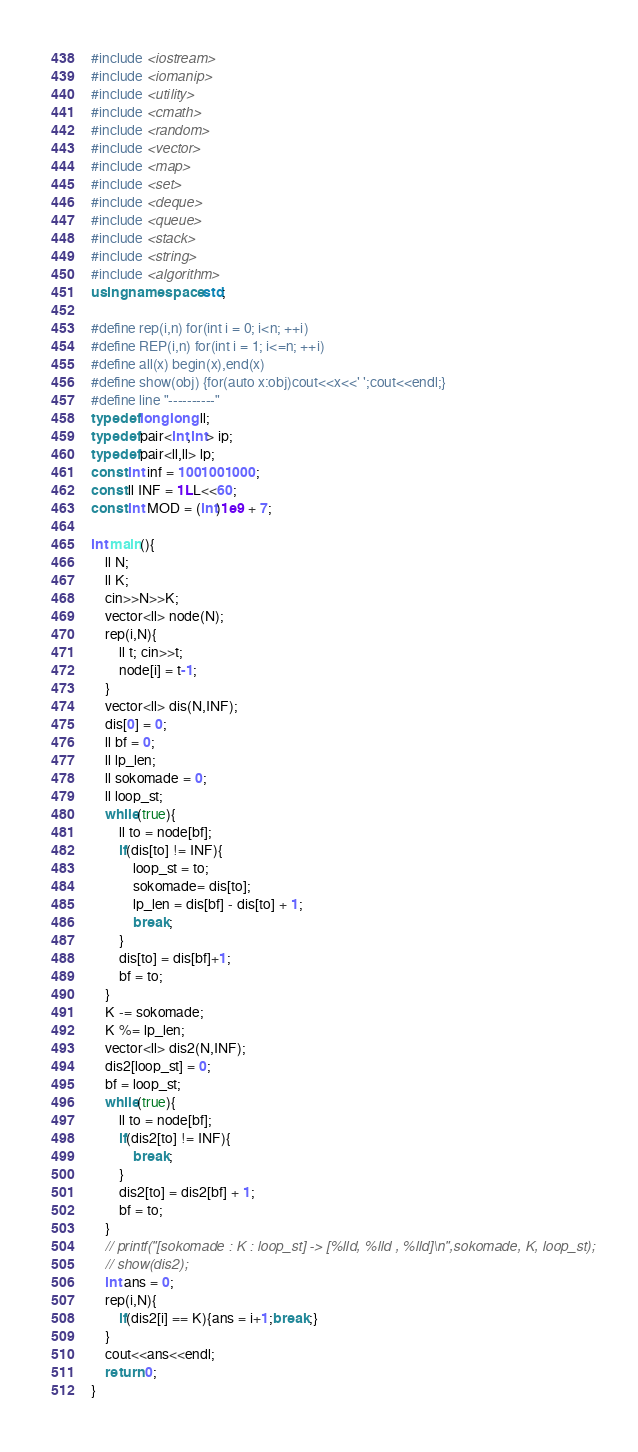Convert code to text. <code><loc_0><loc_0><loc_500><loc_500><_C++_>#include <iostream>
#include <iomanip>
#include <utility>
#include <cmath>
#include <random>
#include <vector>
#include <map>
#include <set>
#include <deque>
#include <queue>
#include <stack>
#include <string>
#include <algorithm>
using namespace std;

#define rep(i,n) for(int i = 0; i<n; ++i)
#define REP(i,n) for(int i = 1; i<=n; ++i)
#define all(x) begin(x),end(x)
#define show(obj) {for(auto x:obj)cout<<x<<' ';cout<<endl;}
#define line "----------"
typedef long long ll;
typedef pair<int,int> ip;
typedef pair<ll,ll> lp;
const int inf = 1001001000;
const ll INF = 1LL<<60;
const int MOD = (int)1e9 + 7;

int main(){
	ll N;
	ll K;
	cin>>N>>K;
	vector<ll> node(N);
	rep(i,N){
		ll t; cin>>t;
		node[i] = t-1;
	}
	vector<ll> dis(N,INF);
	dis[0] = 0;
	ll bf = 0;
	ll lp_len;
	ll sokomade = 0;
	ll loop_st;
	while(true){
		ll to = node[bf];
		if(dis[to] != INF){
			loop_st = to;
			sokomade= dis[to];
			lp_len = dis[bf] - dis[to] + 1;
			break;
		}
		dis[to] = dis[bf]+1;
		bf = to;
	}
	K -= sokomade;
	K %= lp_len;
	vector<ll> dis2(N,INF);
	dis2[loop_st] = 0;
	bf = loop_st;
	while(true){
		ll to = node[bf];
		if(dis2[to] != INF){
			break;
		}
		dis2[to] = dis2[bf] + 1;
		bf = to;
	}
	// printf("[sokomade : K : loop_st] -> [%lld, %lld , %lld]\n",sokomade, K, loop_st);
	// show(dis2);
	int ans = 0;
	rep(i,N){
		if(dis2[i] == K){ans = i+1;break;}
	}
	cout<<ans<<endl;
	return 0;
}</code> 